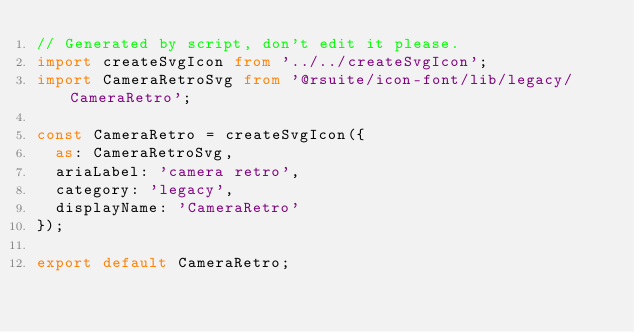<code> <loc_0><loc_0><loc_500><loc_500><_TypeScript_>// Generated by script, don't edit it please.
import createSvgIcon from '../../createSvgIcon';
import CameraRetroSvg from '@rsuite/icon-font/lib/legacy/CameraRetro';

const CameraRetro = createSvgIcon({
  as: CameraRetroSvg,
  ariaLabel: 'camera retro',
  category: 'legacy',
  displayName: 'CameraRetro'
});

export default CameraRetro;
</code> 